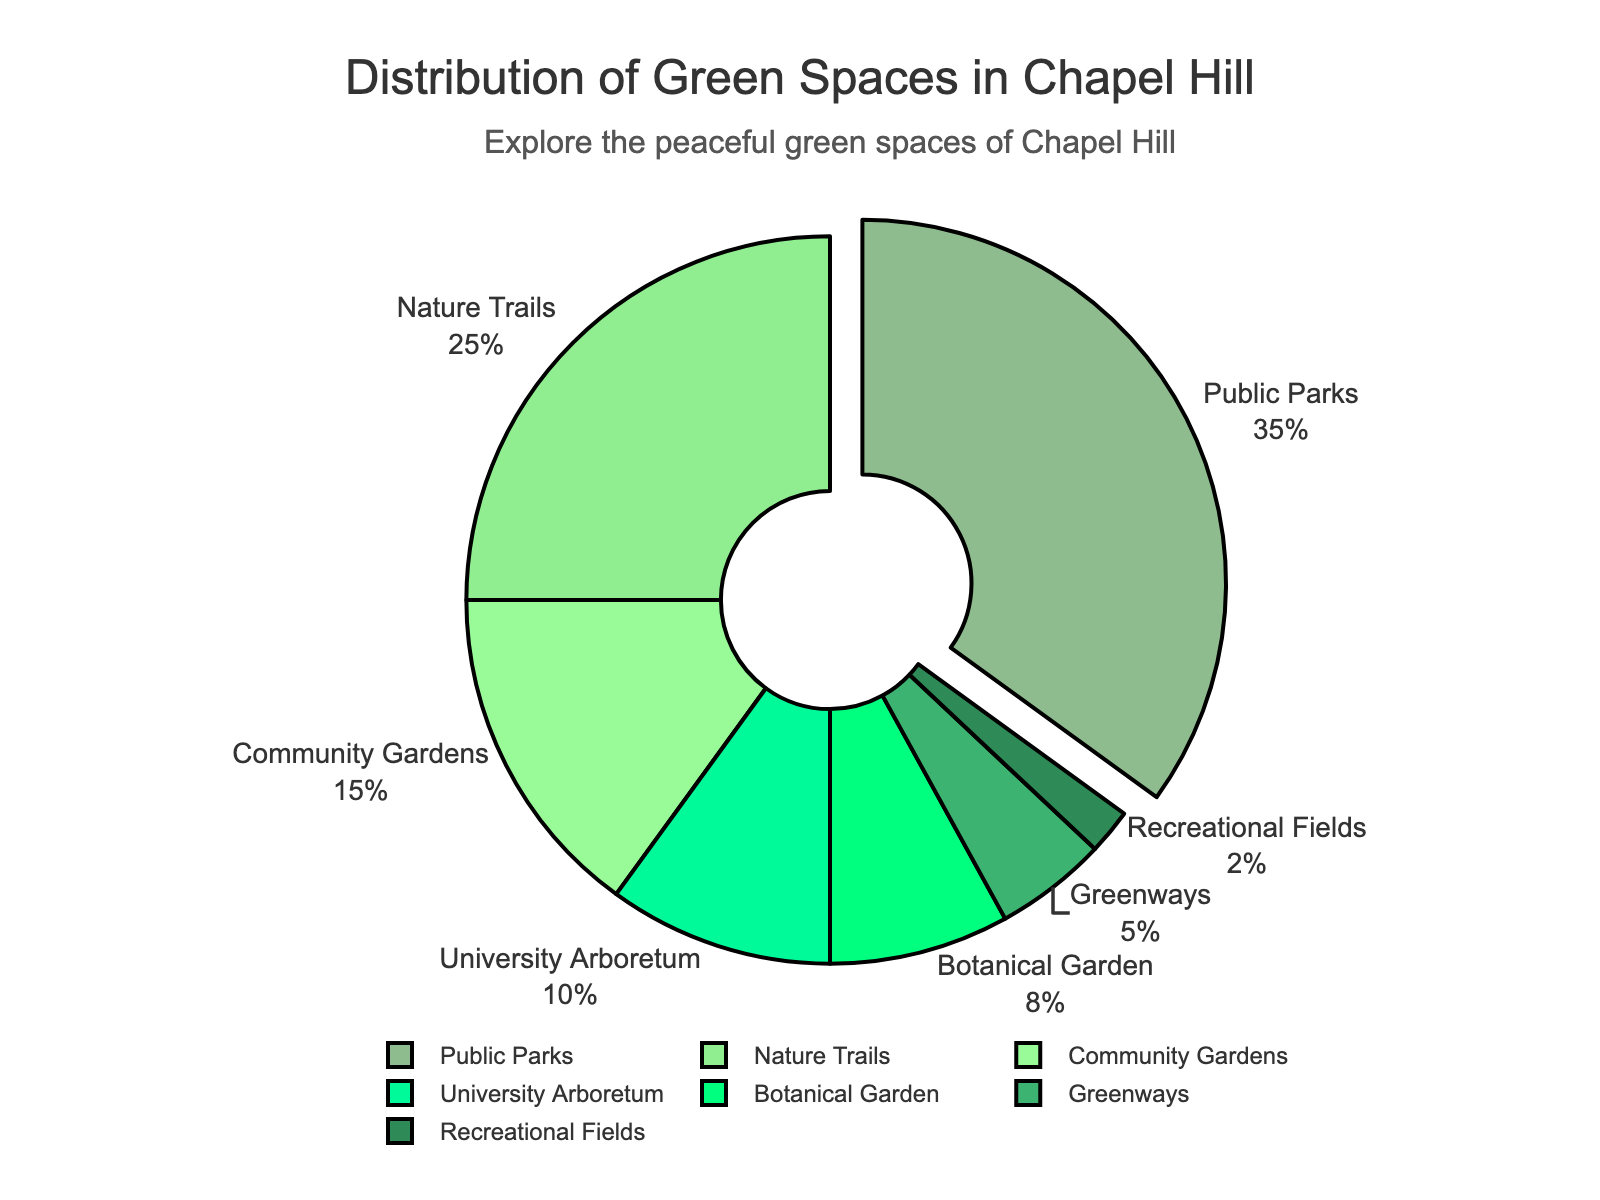What percentage of green spaces is contributed by Community Gardens? The chart shows that Community Gardens account for 15% of the green spaces in Chapel Hill. By referring directly to the labeled segments, we can see the percentage.
Answer: 15% Which type of green space holds the largest percentage? By visually inspecting the pie chart, we see that Public Parks have the largest segment. The chart emphasizes this with a pull-out effect, and we see it labeled as 35%.
Answer: Public Parks How much more percentage do Nature Trails contribute compared to University Arboretum? From the pie chart, Nature Trails account for 25%, and University Arboretum accounts for 10%. Subtract 10% from 25% to find the difference.
Answer: 15% What is the combined percentage of Botanical Garden and Greenways? Identify the percentages for Botanical Garden (8%) and Greenways (5%) and then sum them up. 8% + 5% = 13%.
Answer: 13% Which type of green space contributes the least percentage? Visually, the smallest segment on the pie chart corresponds to Recreational Fields, which is labeled with 2%.
Answer: Recreational Fields How does the percentage contribution of Public Parks compare to that of Community Gardens and Botanical Garden combined? Public Parks have 35%. The combined percentage of Community Gardens and Botanical Garden is 15% + 8% = 23%. Comparing 35% and 23%, Public Parks have a higher percentage.
Answer: Public Parks have more What is the difference between the percentage of Community Gardens and Greenways? The chart shows that Community Gardens contribute 15% and Greenways 5%. Subtract 5% from 15% to get the difference.
Answer: 10% Do Nature Trails and University Arboretum together cover more or less than 35% of the distribution? Nature Trails contribute 25% and University Arboretum 10%. Adding these together, 25% + 10% = 35%.
Answer: Equals 35% What two types of green spaces together contribute 28% of the distribution? To find which two types together make 28%, identify possible combinations from the chart. Botanical Garden (8%) and University Arboretum (10%) don't fit. Next try Greenways (5%) and University Arboretum (10%), Community Gardens (15%) and Botanical Garden (8%), but Nature Trails (25%) and Recreational Fields (2%) together make 25% + 2% = 27%. Finally, Community Gardens (15%) and Greenways (5%) combined make 15% + 5% = 20%, so Botanical Garden (8%) + Community Gardens (15%) = 23%. Verify remaining combinations to identify Community Gardens (15%) and Botanical Garden (8%) which successfully combine to 28%.
Answer: Not possible Arrange the types of green spaces in descending order of contribution. By looking at the percentages, start with the highest and move to the lowest: Public Parks (35%), Nature Trails (25%), Community Gardens (15%), University Arboretum (10%), Botanical Garden (8%), Greenways (5%), Recreational Fields (2%).
Answer: Public Parks, Nature Trails, Community Gardens, University Arboretum, Botanical Garden, Greenways, Recreational Fields 